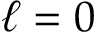<formula> <loc_0><loc_0><loc_500><loc_500>\ell = 0</formula> 